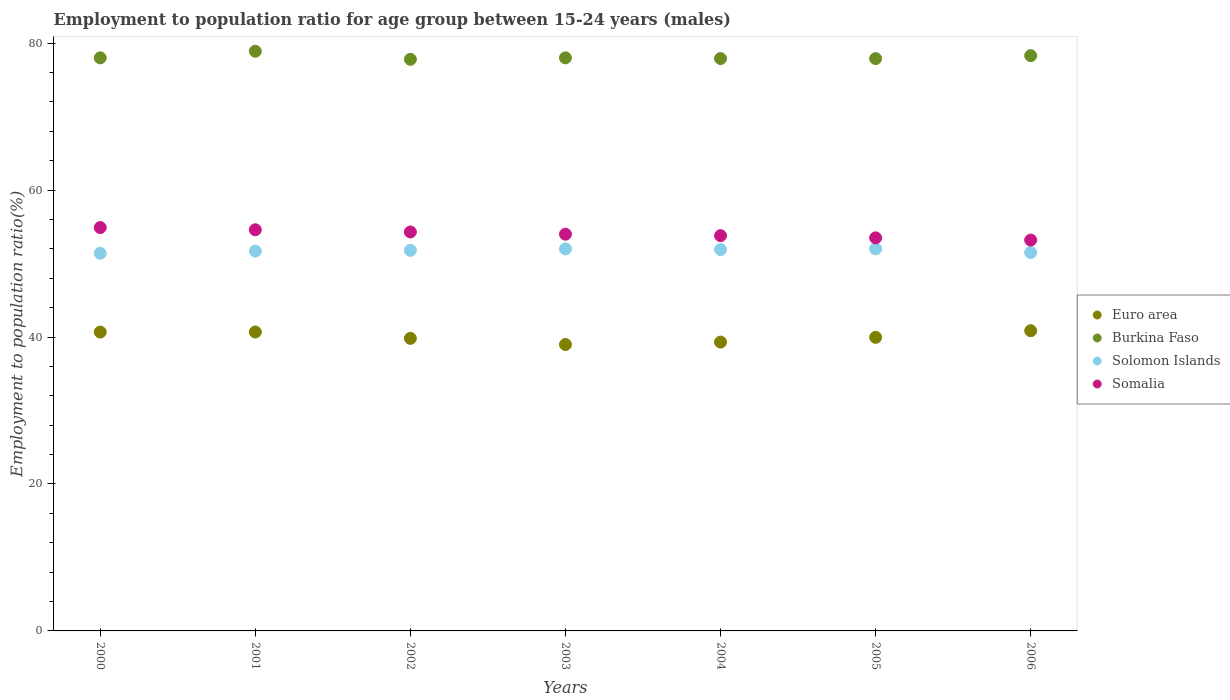How many different coloured dotlines are there?
Offer a terse response. 4. What is the employment to population ratio in Euro area in 2000?
Your answer should be very brief. 40.68. Across all years, what is the maximum employment to population ratio in Somalia?
Keep it short and to the point. 54.9. Across all years, what is the minimum employment to population ratio in Solomon Islands?
Your response must be concise. 51.4. In which year was the employment to population ratio in Solomon Islands minimum?
Your answer should be very brief. 2000. What is the total employment to population ratio in Solomon Islands in the graph?
Ensure brevity in your answer.  362.3. What is the difference between the employment to population ratio in Solomon Islands in 2003 and that in 2006?
Ensure brevity in your answer.  0.5. What is the difference between the employment to population ratio in Burkina Faso in 2004 and the employment to population ratio in Somalia in 2001?
Give a very brief answer. 23.3. What is the average employment to population ratio in Somalia per year?
Provide a succinct answer. 54.04. In the year 2001, what is the difference between the employment to population ratio in Solomon Islands and employment to population ratio in Euro area?
Offer a terse response. 11.02. In how many years, is the employment to population ratio in Solomon Islands greater than 48 %?
Your answer should be compact. 7. What is the ratio of the employment to population ratio in Somalia in 2001 to that in 2004?
Provide a short and direct response. 1.01. Is the employment to population ratio in Burkina Faso in 2000 less than that in 2001?
Provide a succinct answer. Yes. What is the difference between the highest and the second highest employment to population ratio in Somalia?
Keep it short and to the point. 0.3. What is the difference between the highest and the lowest employment to population ratio in Euro area?
Offer a very short reply. 1.88. Does the employment to population ratio in Euro area monotonically increase over the years?
Provide a succinct answer. No. What is the difference between two consecutive major ticks on the Y-axis?
Make the answer very short. 20. Does the graph contain any zero values?
Keep it short and to the point. No. How many legend labels are there?
Your answer should be compact. 4. What is the title of the graph?
Your answer should be compact. Employment to population ratio for age group between 15-24 years (males). What is the label or title of the Y-axis?
Your response must be concise. Employment to population ratio(%). What is the Employment to population ratio(%) of Euro area in 2000?
Make the answer very short. 40.68. What is the Employment to population ratio(%) of Solomon Islands in 2000?
Provide a succinct answer. 51.4. What is the Employment to population ratio(%) of Somalia in 2000?
Provide a succinct answer. 54.9. What is the Employment to population ratio(%) in Euro area in 2001?
Offer a very short reply. 40.68. What is the Employment to population ratio(%) in Burkina Faso in 2001?
Your response must be concise. 78.9. What is the Employment to population ratio(%) in Solomon Islands in 2001?
Keep it short and to the point. 51.7. What is the Employment to population ratio(%) of Somalia in 2001?
Offer a terse response. 54.6. What is the Employment to population ratio(%) in Euro area in 2002?
Keep it short and to the point. 39.82. What is the Employment to population ratio(%) in Burkina Faso in 2002?
Make the answer very short. 77.8. What is the Employment to population ratio(%) of Solomon Islands in 2002?
Ensure brevity in your answer.  51.8. What is the Employment to population ratio(%) of Somalia in 2002?
Your answer should be very brief. 54.3. What is the Employment to population ratio(%) of Euro area in 2003?
Provide a short and direct response. 38.98. What is the Employment to population ratio(%) of Burkina Faso in 2003?
Keep it short and to the point. 78. What is the Employment to population ratio(%) in Solomon Islands in 2003?
Your answer should be very brief. 52. What is the Employment to population ratio(%) in Somalia in 2003?
Your answer should be compact. 54. What is the Employment to population ratio(%) in Euro area in 2004?
Provide a succinct answer. 39.31. What is the Employment to population ratio(%) of Burkina Faso in 2004?
Your answer should be very brief. 77.9. What is the Employment to population ratio(%) of Solomon Islands in 2004?
Keep it short and to the point. 51.9. What is the Employment to population ratio(%) in Somalia in 2004?
Ensure brevity in your answer.  53.8. What is the Employment to population ratio(%) of Euro area in 2005?
Offer a very short reply. 39.96. What is the Employment to population ratio(%) of Burkina Faso in 2005?
Ensure brevity in your answer.  77.9. What is the Employment to population ratio(%) in Somalia in 2005?
Your response must be concise. 53.5. What is the Employment to population ratio(%) in Euro area in 2006?
Offer a very short reply. 40.86. What is the Employment to population ratio(%) in Burkina Faso in 2006?
Make the answer very short. 78.3. What is the Employment to population ratio(%) in Solomon Islands in 2006?
Ensure brevity in your answer.  51.5. What is the Employment to population ratio(%) of Somalia in 2006?
Give a very brief answer. 53.2. Across all years, what is the maximum Employment to population ratio(%) of Euro area?
Offer a very short reply. 40.86. Across all years, what is the maximum Employment to population ratio(%) of Burkina Faso?
Offer a terse response. 78.9. Across all years, what is the maximum Employment to population ratio(%) of Somalia?
Your response must be concise. 54.9. Across all years, what is the minimum Employment to population ratio(%) in Euro area?
Ensure brevity in your answer.  38.98. Across all years, what is the minimum Employment to population ratio(%) of Burkina Faso?
Your answer should be very brief. 77.8. Across all years, what is the minimum Employment to population ratio(%) in Solomon Islands?
Provide a succinct answer. 51.4. Across all years, what is the minimum Employment to population ratio(%) in Somalia?
Offer a very short reply. 53.2. What is the total Employment to population ratio(%) in Euro area in the graph?
Give a very brief answer. 280.3. What is the total Employment to population ratio(%) of Burkina Faso in the graph?
Keep it short and to the point. 546.8. What is the total Employment to population ratio(%) in Solomon Islands in the graph?
Provide a short and direct response. 362.3. What is the total Employment to population ratio(%) in Somalia in the graph?
Offer a terse response. 378.3. What is the difference between the Employment to population ratio(%) of Euro area in 2000 and that in 2001?
Provide a succinct answer. -0.01. What is the difference between the Employment to population ratio(%) of Solomon Islands in 2000 and that in 2001?
Offer a terse response. -0.3. What is the difference between the Employment to population ratio(%) in Euro area in 2000 and that in 2002?
Offer a terse response. 0.85. What is the difference between the Employment to population ratio(%) in Solomon Islands in 2000 and that in 2002?
Provide a succinct answer. -0.4. What is the difference between the Employment to population ratio(%) of Somalia in 2000 and that in 2002?
Keep it short and to the point. 0.6. What is the difference between the Employment to population ratio(%) of Euro area in 2000 and that in 2003?
Your answer should be very brief. 1.69. What is the difference between the Employment to population ratio(%) of Burkina Faso in 2000 and that in 2003?
Keep it short and to the point. 0. What is the difference between the Employment to population ratio(%) of Euro area in 2000 and that in 2004?
Keep it short and to the point. 1.36. What is the difference between the Employment to population ratio(%) in Burkina Faso in 2000 and that in 2004?
Provide a short and direct response. 0.1. What is the difference between the Employment to population ratio(%) of Solomon Islands in 2000 and that in 2004?
Your response must be concise. -0.5. What is the difference between the Employment to population ratio(%) in Euro area in 2000 and that in 2005?
Give a very brief answer. 0.72. What is the difference between the Employment to population ratio(%) in Solomon Islands in 2000 and that in 2005?
Offer a terse response. -0.6. What is the difference between the Employment to population ratio(%) in Somalia in 2000 and that in 2005?
Offer a terse response. 1.4. What is the difference between the Employment to population ratio(%) of Euro area in 2000 and that in 2006?
Keep it short and to the point. -0.19. What is the difference between the Employment to population ratio(%) in Somalia in 2000 and that in 2006?
Your response must be concise. 1.7. What is the difference between the Employment to population ratio(%) in Euro area in 2001 and that in 2002?
Give a very brief answer. 0.86. What is the difference between the Employment to population ratio(%) in Burkina Faso in 2001 and that in 2002?
Offer a very short reply. 1.1. What is the difference between the Employment to population ratio(%) in Somalia in 2001 and that in 2002?
Provide a succinct answer. 0.3. What is the difference between the Employment to population ratio(%) in Euro area in 2001 and that in 2003?
Your answer should be compact. 1.7. What is the difference between the Employment to population ratio(%) in Burkina Faso in 2001 and that in 2003?
Offer a terse response. 0.9. What is the difference between the Employment to population ratio(%) in Euro area in 2001 and that in 2004?
Provide a succinct answer. 1.37. What is the difference between the Employment to population ratio(%) of Burkina Faso in 2001 and that in 2004?
Your answer should be very brief. 1. What is the difference between the Employment to population ratio(%) in Euro area in 2001 and that in 2005?
Keep it short and to the point. 0.73. What is the difference between the Employment to population ratio(%) of Somalia in 2001 and that in 2005?
Ensure brevity in your answer.  1.1. What is the difference between the Employment to population ratio(%) of Euro area in 2001 and that in 2006?
Your answer should be very brief. -0.18. What is the difference between the Employment to population ratio(%) of Burkina Faso in 2001 and that in 2006?
Ensure brevity in your answer.  0.6. What is the difference between the Employment to population ratio(%) of Solomon Islands in 2001 and that in 2006?
Offer a very short reply. 0.2. What is the difference between the Employment to population ratio(%) in Euro area in 2002 and that in 2003?
Your answer should be compact. 0.84. What is the difference between the Employment to population ratio(%) of Burkina Faso in 2002 and that in 2003?
Make the answer very short. -0.2. What is the difference between the Employment to population ratio(%) of Euro area in 2002 and that in 2004?
Provide a succinct answer. 0.51. What is the difference between the Employment to population ratio(%) of Burkina Faso in 2002 and that in 2004?
Offer a very short reply. -0.1. What is the difference between the Employment to population ratio(%) of Solomon Islands in 2002 and that in 2004?
Provide a short and direct response. -0.1. What is the difference between the Employment to population ratio(%) in Somalia in 2002 and that in 2004?
Ensure brevity in your answer.  0.5. What is the difference between the Employment to population ratio(%) of Euro area in 2002 and that in 2005?
Your answer should be very brief. -0.14. What is the difference between the Employment to population ratio(%) in Solomon Islands in 2002 and that in 2005?
Offer a very short reply. -0.2. What is the difference between the Employment to population ratio(%) in Somalia in 2002 and that in 2005?
Ensure brevity in your answer.  0.8. What is the difference between the Employment to population ratio(%) of Euro area in 2002 and that in 2006?
Make the answer very short. -1.04. What is the difference between the Employment to population ratio(%) in Somalia in 2002 and that in 2006?
Provide a succinct answer. 1.1. What is the difference between the Employment to population ratio(%) in Euro area in 2003 and that in 2004?
Your answer should be very brief. -0.33. What is the difference between the Employment to population ratio(%) in Burkina Faso in 2003 and that in 2004?
Keep it short and to the point. 0.1. What is the difference between the Employment to population ratio(%) of Somalia in 2003 and that in 2004?
Give a very brief answer. 0.2. What is the difference between the Employment to population ratio(%) of Euro area in 2003 and that in 2005?
Provide a short and direct response. -0.97. What is the difference between the Employment to population ratio(%) of Somalia in 2003 and that in 2005?
Offer a terse response. 0.5. What is the difference between the Employment to population ratio(%) of Euro area in 2003 and that in 2006?
Provide a short and direct response. -1.88. What is the difference between the Employment to population ratio(%) in Somalia in 2003 and that in 2006?
Your answer should be very brief. 0.8. What is the difference between the Employment to population ratio(%) of Euro area in 2004 and that in 2005?
Provide a succinct answer. -0.64. What is the difference between the Employment to population ratio(%) of Somalia in 2004 and that in 2005?
Provide a succinct answer. 0.3. What is the difference between the Employment to population ratio(%) in Euro area in 2004 and that in 2006?
Provide a short and direct response. -1.55. What is the difference between the Employment to population ratio(%) of Burkina Faso in 2004 and that in 2006?
Provide a short and direct response. -0.4. What is the difference between the Employment to population ratio(%) in Euro area in 2005 and that in 2006?
Your answer should be very brief. -0.9. What is the difference between the Employment to population ratio(%) in Solomon Islands in 2005 and that in 2006?
Your answer should be very brief. 0.5. What is the difference between the Employment to population ratio(%) of Euro area in 2000 and the Employment to population ratio(%) of Burkina Faso in 2001?
Your response must be concise. -38.22. What is the difference between the Employment to population ratio(%) in Euro area in 2000 and the Employment to population ratio(%) in Solomon Islands in 2001?
Provide a short and direct response. -11.02. What is the difference between the Employment to population ratio(%) of Euro area in 2000 and the Employment to population ratio(%) of Somalia in 2001?
Give a very brief answer. -13.92. What is the difference between the Employment to population ratio(%) of Burkina Faso in 2000 and the Employment to population ratio(%) of Solomon Islands in 2001?
Give a very brief answer. 26.3. What is the difference between the Employment to population ratio(%) in Burkina Faso in 2000 and the Employment to population ratio(%) in Somalia in 2001?
Keep it short and to the point. 23.4. What is the difference between the Employment to population ratio(%) of Euro area in 2000 and the Employment to population ratio(%) of Burkina Faso in 2002?
Provide a short and direct response. -37.12. What is the difference between the Employment to population ratio(%) of Euro area in 2000 and the Employment to population ratio(%) of Solomon Islands in 2002?
Offer a terse response. -11.12. What is the difference between the Employment to population ratio(%) in Euro area in 2000 and the Employment to population ratio(%) in Somalia in 2002?
Keep it short and to the point. -13.62. What is the difference between the Employment to population ratio(%) in Burkina Faso in 2000 and the Employment to population ratio(%) in Solomon Islands in 2002?
Give a very brief answer. 26.2. What is the difference between the Employment to population ratio(%) in Burkina Faso in 2000 and the Employment to population ratio(%) in Somalia in 2002?
Make the answer very short. 23.7. What is the difference between the Employment to population ratio(%) in Solomon Islands in 2000 and the Employment to population ratio(%) in Somalia in 2002?
Keep it short and to the point. -2.9. What is the difference between the Employment to population ratio(%) in Euro area in 2000 and the Employment to population ratio(%) in Burkina Faso in 2003?
Your answer should be compact. -37.32. What is the difference between the Employment to population ratio(%) of Euro area in 2000 and the Employment to population ratio(%) of Solomon Islands in 2003?
Offer a very short reply. -11.32. What is the difference between the Employment to population ratio(%) in Euro area in 2000 and the Employment to population ratio(%) in Somalia in 2003?
Your response must be concise. -13.32. What is the difference between the Employment to population ratio(%) of Burkina Faso in 2000 and the Employment to population ratio(%) of Solomon Islands in 2003?
Ensure brevity in your answer.  26. What is the difference between the Employment to population ratio(%) in Solomon Islands in 2000 and the Employment to population ratio(%) in Somalia in 2003?
Make the answer very short. -2.6. What is the difference between the Employment to population ratio(%) in Euro area in 2000 and the Employment to population ratio(%) in Burkina Faso in 2004?
Your answer should be compact. -37.22. What is the difference between the Employment to population ratio(%) of Euro area in 2000 and the Employment to population ratio(%) of Solomon Islands in 2004?
Provide a short and direct response. -11.22. What is the difference between the Employment to population ratio(%) of Euro area in 2000 and the Employment to population ratio(%) of Somalia in 2004?
Your answer should be very brief. -13.12. What is the difference between the Employment to population ratio(%) in Burkina Faso in 2000 and the Employment to population ratio(%) in Solomon Islands in 2004?
Your response must be concise. 26.1. What is the difference between the Employment to population ratio(%) of Burkina Faso in 2000 and the Employment to population ratio(%) of Somalia in 2004?
Make the answer very short. 24.2. What is the difference between the Employment to population ratio(%) of Euro area in 2000 and the Employment to population ratio(%) of Burkina Faso in 2005?
Offer a terse response. -37.22. What is the difference between the Employment to population ratio(%) in Euro area in 2000 and the Employment to population ratio(%) in Solomon Islands in 2005?
Offer a very short reply. -11.32. What is the difference between the Employment to population ratio(%) of Euro area in 2000 and the Employment to population ratio(%) of Somalia in 2005?
Provide a short and direct response. -12.82. What is the difference between the Employment to population ratio(%) in Burkina Faso in 2000 and the Employment to population ratio(%) in Solomon Islands in 2005?
Your answer should be compact. 26. What is the difference between the Employment to population ratio(%) in Euro area in 2000 and the Employment to population ratio(%) in Burkina Faso in 2006?
Offer a very short reply. -37.62. What is the difference between the Employment to population ratio(%) of Euro area in 2000 and the Employment to population ratio(%) of Solomon Islands in 2006?
Provide a succinct answer. -10.82. What is the difference between the Employment to population ratio(%) in Euro area in 2000 and the Employment to population ratio(%) in Somalia in 2006?
Ensure brevity in your answer.  -12.52. What is the difference between the Employment to population ratio(%) in Burkina Faso in 2000 and the Employment to population ratio(%) in Somalia in 2006?
Keep it short and to the point. 24.8. What is the difference between the Employment to population ratio(%) of Solomon Islands in 2000 and the Employment to population ratio(%) of Somalia in 2006?
Keep it short and to the point. -1.8. What is the difference between the Employment to population ratio(%) of Euro area in 2001 and the Employment to population ratio(%) of Burkina Faso in 2002?
Keep it short and to the point. -37.12. What is the difference between the Employment to population ratio(%) of Euro area in 2001 and the Employment to population ratio(%) of Solomon Islands in 2002?
Offer a terse response. -11.12. What is the difference between the Employment to population ratio(%) of Euro area in 2001 and the Employment to population ratio(%) of Somalia in 2002?
Provide a succinct answer. -13.62. What is the difference between the Employment to population ratio(%) of Burkina Faso in 2001 and the Employment to population ratio(%) of Solomon Islands in 2002?
Your response must be concise. 27.1. What is the difference between the Employment to population ratio(%) in Burkina Faso in 2001 and the Employment to population ratio(%) in Somalia in 2002?
Your response must be concise. 24.6. What is the difference between the Employment to population ratio(%) in Solomon Islands in 2001 and the Employment to population ratio(%) in Somalia in 2002?
Offer a very short reply. -2.6. What is the difference between the Employment to population ratio(%) in Euro area in 2001 and the Employment to population ratio(%) in Burkina Faso in 2003?
Offer a very short reply. -37.32. What is the difference between the Employment to population ratio(%) of Euro area in 2001 and the Employment to population ratio(%) of Solomon Islands in 2003?
Provide a short and direct response. -11.32. What is the difference between the Employment to population ratio(%) of Euro area in 2001 and the Employment to population ratio(%) of Somalia in 2003?
Ensure brevity in your answer.  -13.32. What is the difference between the Employment to population ratio(%) of Burkina Faso in 2001 and the Employment to population ratio(%) of Solomon Islands in 2003?
Offer a terse response. 26.9. What is the difference between the Employment to population ratio(%) of Burkina Faso in 2001 and the Employment to population ratio(%) of Somalia in 2003?
Keep it short and to the point. 24.9. What is the difference between the Employment to population ratio(%) in Solomon Islands in 2001 and the Employment to population ratio(%) in Somalia in 2003?
Keep it short and to the point. -2.3. What is the difference between the Employment to population ratio(%) of Euro area in 2001 and the Employment to population ratio(%) of Burkina Faso in 2004?
Ensure brevity in your answer.  -37.22. What is the difference between the Employment to population ratio(%) in Euro area in 2001 and the Employment to population ratio(%) in Solomon Islands in 2004?
Ensure brevity in your answer.  -11.22. What is the difference between the Employment to population ratio(%) in Euro area in 2001 and the Employment to population ratio(%) in Somalia in 2004?
Offer a very short reply. -13.12. What is the difference between the Employment to population ratio(%) of Burkina Faso in 2001 and the Employment to population ratio(%) of Solomon Islands in 2004?
Ensure brevity in your answer.  27. What is the difference between the Employment to population ratio(%) of Burkina Faso in 2001 and the Employment to population ratio(%) of Somalia in 2004?
Your answer should be compact. 25.1. What is the difference between the Employment to population ratio(%) of Euro area in 2001 and the Employment to population ratio(%) of Burkina Faso in 2005?
Your response must be concise. -37.22. What is the difference between the Employment to population ratio(%) of Euro area in 2001 and the Employment to population ratio(%) of Solomon Islands in 2005?
Your answer should be very brief. -11.32. What is the difference between the Employment to population ratio(%) of Euro area in 2001 and the Employment to population ratio(%) of Somalia in 2005?
Ensure brevity in your answer.  -12.82. What is the difference between the Employment to population ratio(%) of Burkina Faso in 2001 and the Employment to population ratio(%) of Solomon Islands in 2005?
Your answer should be very brief. 26.9. What is the difference between the Employment to population ratio(%) of Burkina Faso in 2001 and the Employment to population ratio(%) of Somalia in 2005?
Your answer should be very brief. 25.4. What is the difference between the Employment to population ratio(%) in Euro area in 2001 and the Employment to population ratio(%) in Burkina Faso in 2006?
Provide a succinct answer. -37.62. What is the difference between the Employment to population ratio(%) of Euro area in 2001 and the Employment to population ratio(%) of Solomon Islands in 2006?
Keep it short and to the point. -10.82. What is the difference between the Employment to population ratio(%) in Euro area in 2001 and the Employment to population ratio(%) in Somalia in 2006?
Make the answer very short. -12.52. What is the difference between the Employment to population ratio(%) of Burkina Faso in 2001 and the Employment to population ratio(%) of Solomon Islands in 2006?
Make the answer very short. 27.4. What is the difference between the Employment to population ratio(%) of Burkina Faso in 2001 and the Employment to population ratio(%) of Somalia in 2006?
Ensure brevity in your answer.  25.7. What is the difference between the Employment to population ratio(%) of Euro area in 2002 and the Employment to population ratio(%) of Burkina Faso in 2003?
Offer a terse response. -38.18. What is the difference between the Employment to population ratio(%) of Euro area in 2002 and the Employment to population ratio(%) of Solomon Islands in 2003?
Your answer should be very brief. -12.18. What is the difference between the Employment to population ratio(%) of Euro area in 2002 and the Employment to population ratio(%) of Somalia in 2003?
Your response must be concise. -14.18. What is the difference between the Employment to population ratio(%) of Burkina Faso in 2002 and the Employment to population ratio(%) of Solomon Islands in 2003?
Give a very brief answer. 25.8. What is the difference between the Employment to population ratio(%) in Burkina Faso in 2002 and the Employment to population ratio(%) in Somalia in 2003?
Give a very brief answer. 23.8. What is the difference between the Employment to population ratio(%) of Solomon Islands in 2002 and the Employment to population ratio(%) of Somalia in 2003?
Provide a short and direct response. -2.2. What is the difference between the Employment to population ratio(%) of Euro area in 2002 and the Employment to population ratio(%) of Burkina Faso in 2004?
Offer a terse response. -38.08. What is the difference between the Employment to population ratio(%) of Euro area in 2002 and the Employment to population ratio(%) of Solomon Islands in 2004?
Your answer should be compact. -12.08. What is the difference between the Employment to population ratio(%) of Euro area in 2002 and the Employment to population ratio(%) of Somalia in 2004?
Your answer should be compact. -13.98. What is the difference between the Employment to population ratio(%) of Burkina Faso in 2002 and the Employment to population ratio(%) of Solomon Islands in 2004?
Offer a terse response. 25.9. What is the difference between the Employment to population ratio(%) in Burkina Faso in 2002 and the Employment to population ratio(%) in Somalia in 2004?
Your response must be concise. 24. What is the difference between the Employment to population ratio(%) in Solomon Islands in 2002 and the Employment to population ratio(%) in Somalia in 2004?
Ensure brevity in your answer.  -2. What is the difference between the Employment to population ratio(%) of Euro area in 2002 and the Employment to population ratio(%) of Burkina Faso in 2005?
Give a very brief answer. -38.08. What is the difference between the Employment to population ratio(%) of Euro area in 2002 and the Employment to population ratio(%) of Solomon Islands in 2005?
Give a very brief answer. -12.18. What is the difference between the Employment to population ratio(%) of Euro area in 2002 and the Employment to population ratio(%) of Somalia in 2005?
Make the answer very short. -13.68. What is the difference between the Employment to population ratio(%) of Burkina Faso in 2002 and the Employment to population ratio(%) of Solomon Islands in 2005?
Your answer should be compact. 25.8. What is the difference between the Employment to population ratio(%) of Burkina Faso in 2002 and the Employment to population ratio(%) of Somalia in 2005?
Give a very brief answer. 24.3. What is the difference between the Employment to population ratio(%) in Solomon Islands in 2002 and the Employment to population ratio(%) in Somalia in 2005?
Ensure brevity in your answer.  -1.7. What is the difference between the Employment to population ratio(%) in Euro area in 2002 and the Employment to population ratio(%) in Burkina Faso in 2006?
Keep it short and to the point. -38.48. What is the difference between the Employment to population ratio(%) in Euro area in 2002 and the Employment to population ratio(%) in Solomon Islands in 2006?
Offer a very short reply. -11.68. What is the difference between the Employment to population ratio(%) in Euro area in 2002 and the Employment to population ratio(%) in Somalia in 2006?
Provide a short and direct response. -13.38. What is the difference between the Employment to population ratio(%) of Burkina Faso in 2002 and the Employment to population ratio(%) of Solomon Islands in 2006?
Make the answer very short. 26.3. What is the difference between the Employment to population ratio(%) of Burkina Faso in 2002 and the Employment to population ratio(%) of Somalia in 2006?
Give a very brief answer. 24.6. What is the difference between the Employment to population ratio(%) in Euro area in 2003 and the Employment to population ratio(%) in Burkina Faso in 2004?
Provide a succinct answer. -38.92. What is the difference between the Employment to population ratio(%) of Euro area in 2003 and the Employment to population ratio(%) of Solomon Islands in 2004?
Offer a very short reply. -12.92. What is the difference between the Employment to population ratio(%) of Euro area in 2003 and the Employment to population ratio(%) of Somalia in 2004?
Provide a succinct answer. -14.82. What is the difference between the Employment to population ratio(%) of Burkina Faso in 2003 and the Employment to population ratio(%) of Solomon Islands in 2004?
Your response must be concise. 26.1. What is the difference between the Employment to population ratio(%) in Burkina Faso in 2003 and the Employment to population ratio(%) in Somalia in 2004?
Your answer should be very brief. 24.2. What is the difference between the Employment to population ratio(%) of Solomon Islands in 2003 and the Employment to population ratio(%) of Somalia in 2004?
Offer a terse response. -1.8. What is the difference between the Employment to population ratio(%) in Euro area in 2003 and the Employment to population ratio(%) in Burkina Faso in 2005?
Ensure brevity in your answer.  -38.92. What is the difference between the Employment to population ratio(%) of Euro area in 2003 and the Employment to population ratio(%) of Solomon Islands in 2005?
Your answer should be very brief. -13.02. What is the difference between the Employment to population ratio(%) of Euro area in 2003 and the Employment to population ratio(%) of Somalia in 2005?
Your answer should be compact. -14.52. What is the difference between the Employment to population ratio(%) in Solomon Islands in 2003 and the Employment to population ratio(%) in Somalia in 2005?
Provide a short and direct response. -1.5. What is the difference between the Employment to population ratio(%) in Euro area in 2003 and the Employment to population ratio(%) in Burkina Faso in 2006?
Keep it short and to the point. -39.32. What is the difference between the Employment to population ratio(%) of Euro area in 2003 and the Employment to population ratio(%) of Solomon Islands in 2006?
Your response must be concise. -12.52. What is the difference between the Employment to population ratio(%) in Euro area in 2003 and the Employment to population ratio(%) in Somalia in 2006?
Your answer should be compact. -14.22. What is the difference between the Employment to population ratio(%) of Burkina Faso in 2003 and the Employment to population ratio(%) of Somalia in 2006?
Make the answer very short. 24.8. What is the difference between the Employment to population ratio(%) in Solomon Islands in 2003 and the Employment to population ratio(%) in Somalia in 2006?
Ensure brevity in your answer.  -1.2. What is the difference between the Employment to population ratio(%) in Euro area in 2004 and the Employment to population ratio(%) in Burkina Faso in 2005?
Ensure brevity in your answer.  -38.59. What is the difference between the Employment to population ratio(%) of Euro area in 2004 and the Employment to population ratio(%) of Solomon Islands in 2005?
Provide a short and direct response. -12.69. What is the difference between the Employment to population ratio(%) of Euro area in 2004 and the Employment to population ratio(%) of Somalia in 2005?
Keep it short and to the point. -14.19. What is the difference between the Employment to population ratio(%) of Burkina Faso in 2004 and the Employment to population ratio(%) of Solomon Islands in 2005?
Your answer should be very brief. 25.9. What is the difference between the Employment to population ratio(%) of Burkina Faso in 2004 and the Employment to population ratio(%) of Somalia in 2005?
Offer a very short reply. 24.4. What is the difference between the Employment to population ratio(%) of Solomon Islands in 2004 and the Employment to population ratio(%) of Somalia in 2005?
Offer a very short reply. -1.6. What is the difference between the Employment to population ratio(%) of Euro area in 2004 and the Employment to population ratio(%) of Burkina Faso in 2006?
Offer a very short reply. -38.98. What is the difference between the Employment to population ratio(%) of Euro area in 2004 and the Employment to population ratio(%) of Solomon Islands in 2006?
Your answer should be very brief. -12.19. What is the difference between the Employment to population ratio(%) in Euro area in 2004 and the Employment to population ratio(%) in Somalia in 2006?
Make the answer very short. -13.88. What is the difference between the Employment to population ratio(%) in Burkina Faso in 2004 and the Employment to population ratio(%) in Solomon Islands in 2006?
Ensure brevity in your answer.  26.4. What is the difference between the Employment to population ratio(%) in Burkina Faso in 2004 and the Employment to population ratio(%) in Somalia in 2006?
Your answer should be compact. 24.7. What is the difference between the Employment to population ratio(%) in Solomon Islands in 2004 and the Employment to population ratio(%) in Somalia in 2006?
Your answer should be compact. -1.3. What is the difference between the Employment to population ratio(%) in Euro area in 2005 and the Employment to population ratio(%) in Burkina Faso in 2006?
Make the answer very short. -38.34. What is the difference between the Employment to population ratio(%) of Euro area in 2005 and the Employment to population ratio(%) of Solomon Islands in 2006?
Offer a terse response. -11.54. What is the difference between the Employment to population ratio(%) of Euro area in 2005 and the Employment to population ratio(%) of Somalia in 2006?
Your answer should be compact. -13.24. What is the difference between the Employment to population ratio(%) in Burkina Faso in 2005 and the Employment to population ratio(%) in Solomon Islands in 2006?
Provide a succinct answer. 26.4. What is the difference between the Employment to population ratio(%) of Burkina Faso in 2005 and the Employment to population ratio(%) of Somalia in 2006?
Ensure brevity in your answer.  24.7. What is the average Employment to population ratio(%) in Euro area per year?
Make the answer very short. 40.04. What is the average Employment to population ratio(%) in Burkina Faso per year?
Offer a very short reply. 78.11. What is the average Employment to population ratio(%) of Solomon Islands per year?
Keep it short and to the point. 51.76. What is the average Employment to population ratio(%) in Somalia per year?
Offer a terse response. 54.04. In the year 2000, what is the difference between the Employment to population ratio(%) in Euro area and Employment to population ratio(%) in Burkina Faso?
Your response must be concise. -37.32. In the year 2000, what is the difference between the Employment to population ratio(%) in Euro area and Employment to population ratio(%) in Solomon Islands?
Offer a terse response. -10.72. In the year 2000, what is the difference between the Employment to population ratio(%) in Euro area and Employment to population ratio(%) in Somalia?
Your answer should be compact. -14.22. In the year 2000, what is the difference between the Employment to population ratio(%) in Burkina Faso and Employment to population ratio(%) in Solomon Islands?
Your answer should be very brief. 26.6. In the year 2000, what is the difference between the Employment to population ratio(%) in Burkina Faso and Employment to population ratio(%) in Somalia?
Provide a succinct answer. 23.1. In the year 2001, what is the difference between the Employment to population ratio(%) in Euro area and Employment to population ratio(%) in Burkina Faso?
Your answer should be very brief. -38.22. In the year 2001, what is the difference between the Employment to population ratio(%) of Euro area and Employment to population ratio(%) of Solomon Islands?
Make the answer very short. -11.02. In the year 2001, what is the difference between the Employment to population ratio(%) of Euro area and Employment to population ratio(%) of Somalia?
Give a very brief answer. -13.92. In the year 2001, what is the difference between the Employment to population ratio(%) of Burkina Faso and Employment to population ratio(%) of Solomon Islands?
Ensure brevity in your answer.  27.2. In the year 2001, what is the difference between the Employment to population ratio(%) in Burkina Faso and Employment to population ratio(%) in Somalia?
Provide a short and direct response. 24.3. In the year 2001, what is the difference between the Employment to population ratio(%) of Solomon Islands and Employment to population ratio(%) of Somalia?
Provide a succinct answer. -2.9. In the year 2002, what is the difference between the Employment to population ratio(%) of Euro area and Employment to population ratio(%) of Burkina Faso?
Make the answer very short. -37.98. In the year 2002, what is the difference between the Employment to population ratio(%) of Euro area and Employment to population ratio(%) of Solomon Islands?
Your response must be concise. -11.98. In the year 2002, what is the difference between the Employment to population ratio(%) in Euro area and Employment to population ratio(%) in Somalia?
Offer a very short reply. -14.48. In the year 2002, what is the difference between the Employment to population ratio(%) of Burkina Faso and Employment to population ratio(%) of Somalia?
Provide a short and direct response. 23.5. In the year 2003, what is the difference between the Employment to population ratio(%) in Euro area and Employment to population ratio(%) in Burkina Faso?
Your answer should be very brief. -39.02. In the year 2003, what is the difference between the Employment to population ratio(%) in Euro area and Employment to population ratio(%) in Solomon Islands?
Give a very brief answer. -13.02. In the year 2003, what is the difference between the Employment to population ratio(%) of Euro area and Employment to population ratio(%) of Somalia?
Make the answer very short. -15.02. In the year 2004, what is the difference between the Employment to population ratio(%) of Euro area and Employment to population ratio(%) of Burkina Faso?
Make the answer very short. -38.59. In the year 2004, what is the difference between the Employment to population ratio(%) of Euro area and Employment to population ratio(%) of Solomon Islands?
Your answer should be very brief. -12.59. In the year 2004, what is the difference between the Employment to population ratio(%) of Euro area and Employment to population ratio(%) of Somalia?
Ensure brevity in your answer.  -14.48. In the year 2004, what is the difference between the Employment to population ratio(%) of Burkina Faso and Employment to population ratio(%) of Solomon Islands?
Your answer should be very brief. 26. In the year 2004, what is the difference between the Employment to population ratio(%) of Burkina Faso and Employment to population ratio(%) of Somalia?
Ensure brevity in your answer.  24.1. In the year 2005, what is the difference between the Employment to population ratio(%) of Euro area and Employment to population ratio(%) of Burkina Faso?
Make the answer very short. -37.94. In the year 2005, what is the difference between the Employment to population ratio(%) of Euro area and Employment to population ratio(%) of Solomon Islands?
Offer a very short reply. -12.04. In the year 2005, what is the difference between the Employment to population ratio(%) of Euro area and Employment to population ratio(%) of Somalia?
Keep it short and to the point. -13.54. In the year 2005, what is the difference between the Employment to population ratio(%) of Burkina Faso and Employment to population ratio(%) of Solomon Islands?
Provide a short and direct response. 25.9. In the year 2005, what is the difference between the Employment to population ratio(%) of Burkina Faso and Employment to population ratio(%) of Somalia?
Offer a terse response. 24.4. In the year 2006, what is the difference between the Employment to population ratio(%) of Euro area and Employment to population ratio(%) of Burkina Faso?
Offer a very short reply. -37.44. In the year 2006, what is the difference between the Employment to population ratio(%) of Euro area and Employment to population ratio(%) of Solomon Islands?
Your response must be concise. -10.64. In the year 2006, what is the difference between the Employment to population ratio(%) of Euro area and Employment to population ratio(%) of Somalia?
Provide a short and direct response. -12.34. In the year 2006, what is the difference between the Employment to population ratio(%) of Burkina Faso and Employment to population ratio(%) of Solomon Islands?
Your answer should be compact. 26.8. In the year 2006, what is the difference between the Employment to population ratio(%) of Burkina Faso and Employment to population ratio(%) of Somalia?
Keep it short and to the point. 25.1. What is the ratio of the Employment to population ratio(%) of Euro area in 2000 to that in 2001?
Your answer should be compact. 1. What is the ratio of the Employment to population ratio(%) of Euro area in 2000 to that in 2002?
Make the answer very short. 1.02. What is the ratio of the Employment to population ratio(%) of Burkina Faso in 2000 to that in 2002?
Offer a very short reply. 1. What is the ratio of the Employment to population ratio(%) in Somalia in 2000 to that in 2002?
Offer a very short reply. 1.01. What is the ratio of the Employment to population ratio(%) in Euro area in 2000 to that in 2003?
Offer a very short reply. 1.04. What is the ratio of the Employment to population ratio(%) in Burkina Faso in 2000 to that in 2003?
Your answer should be compact. 1. What is the ratio of the Employment to population ratio(%) in Somalia in 2000 to that in 2003?
Offer a very short reply. 1.02. What is the ratio of the Employment to population ratio(%) of Euro area in 2000 to that in 2004?
Provide a succinct answer. 1.03. What is the ratio of the Employment to population ratio(%) of Solomon Islands in 2000 to that in 2004?
Make the answer very short. 0.99. What is the ratio of the Employment to population ratio(%) in Somalia in 2000 to that in 2004?
Your response must be concise. 1.02. What is the ratio of the Employment to population ratio(%) of Euro area in 2000 to that in 2005?
Keep it short and to the point. 1.02. What is the ratio of the Employment to population ratio(%) of Solomon Islands in 2000 to that in 2005?
Your answer should be compact. 0.99. What is the ratio of the Employment to population ratio(%) in Somalia in 2000 to that in 2005?
Your answer should be very brief. 1.03. What is the ratio of the Employment to population ratio(%) of Solomon Islands in 2000 to that in 2006?
Give a very brief answer. 1. What is the ratio of the Employment to population ratio(%) of Somalia in 2000 to that in 2006?
Your answer should be very brief. 1.03. What is the ratio of the Employment to population ratio(%) of Euro area in 2001 to that in 2002?
Give a very brief answer. 1.02. What is the ratio of the Employment to population ratio(%) in Burkina Faso in 2001 to that in 2002?
Offer a very short reply. 1.01. What is the ratio of the Employment to population ratio(%) in Solomon Islands in 2001 to that in 2002?
Make the answer very short. 1. What is the ratio of the Employment to population ratio(%) in Somalia in 2001 to that in 2002?
Provide a short and direct response. 1.01. What is the ratio of the Employment to population ratio(%) in Euro area in 2001 to that in 2003?
Ensure brevity in your answer.  1.04. What is the ratio of the Employment to population ratio(%) of Burkina Faso in 2001 to that in 2003?
Keep it short and to the point. 1.01. What is the ratio of the Employment to population ratio(%) in Solomon Islands in 2001 to that in 2003?
Offer a very short reply. 0.99. What is the ratio of the Employment to population ratio(%) in Somalia in 2001 to that in 2003?
Make the answer very short. 1.01. What is the ratio of the Employment to population ratio(%) of Euro area in 2001 to that in 2004?
Provide a succinct answer. 1.03. What is the ratio of the Employment to population ratio(%) of Burkina Faso in 2001 to that in 2004?
Your answer should be compact. 1.01. What is the ratio of the Employment to population ratio(%) of Solomon Islands in 2001 to that in 2004?
Offer a terse response. 1. What is the ratio of the Employment to population ratio(%) of Somalia in 2001 to that in 2004?
Ensure brevity in your answer.  1.01. What is the ratio of the Employment to population ratio(%) of Euro area in 2001 to that in 2005?
Ensure brevity in your answer.  1.02. What is the ratio of the Employment to population ratio(%) in Burkina Faso in 2001 to that in 2005?
Offer a very short reply. 1.01. What is the ratio of the Employment to population ratio(%) in Solomon Islands in 2001 to that in 2005?
Provide a short and direct response. 0.99. What is the ratio of the Employment to population ratio(%) in Somalia in 2001 to that in 2005?
Keep it short and to the point. 1.02. What is the ratio of the Employment to population ratio(%) in Euro area in 2001 to that in 2006?
Make the answer very short. 1. What is the ratio of the Employment to population ratio(%) in Burkina Faso in 2001 to that in 2006?
Offer a terse response. 1.01. What is the ratio of the Employment to population ratio(%) in Somalia in 2001 to that in 2006?
Make the answer very short. 1.03. What is the ratio of the Employment to population ratio(%) of Euro area in 2002 to that in 2003?
Your answer should be compact. 1.02. What is the ratio of the Employment to population ratio(%) in Solomon Islands in 2002 to that in 2003?
Provide a succinct answer. 1. What is the ratio of the Employment to population ratio(%) in Somalia in 2002 to that in 2003?
Ensure brevity in your answer.  1.01. What is the ratio of the Employment to population ratio(%) of Euro area in 2002 to that in 2004?
Ensure brevity in your answer.  1.01. What is the ratio of the Employment to population ratio(%) of Solomon Islands in 2002 to that in 2004?
Give a very brief answer. 1. What is the ratio of the Employment to population ratio(%) of Somalia in 2002 to that in 2004?
Give a very brief answer. 1.01. What is the ratio of the Employment to population ratio(%) in Burkina Faso in 2002 to that in 2005?
Provide a succinct answer. 1. What is the ratio of the Employment to population ratio(%) in Somalia in 2002 to that in 2005?
Your answer should be compact. 1.01. What is the ratio of the Employment to population ratio(%) of Euro area in 2002 to that in 2006?
Your answer should be compact. 0.97. What is the ratio of the Employment to population ratio(%) in Burkina Faso in 2002 to that in 2006?
Offer a terse response. 0.99. What is the ratio of the Employment to population ratio(%) in Somalia in 2002 to that in 2006?
Your answer should be compact. 1.02. What is the ratio of the Employment to population ratio(%) of Euro area in 2003 to that in 2004?
Provide a short and direct response. 0.99. What is the ratio of the Employment to population ratio(%) in Burkina Faso in 2003 to that in 2004?
Ensure brevity in your answer.  1. What is the ratio of the Employment to population ratio(%) in Euro area in 2003 to that in 2005?
Offer a very short reply. 0.98. What is the ratio of the Employment to population ratio(%) in Burkina Faso in 2003 to that in 2005?
Offer a very short reply. 1. What is the ratio of the Employment to population ratio(%) in Somalia in 2003 to that in 2005?
Give a very brief answer. 1.01. What is the ratio of the Employment to population ratio(%) in Euro area in 2003 to that in 2006?
Your answer should be compact. 0.95. What is the ratio of the Employment to population ratio(%) of Burkina Faso in 2003 to that in 2006?
Ensure brevity in your answer.  1. What is the ratio of the Employment to population ratio(%) in Solomon Islands in 2003 to that in 2006?
Keep it short and to the point. 1.01. What is the ratio of the Employment to population ratio(%) of Somalia in 2003 to that in 2006?
Keep it short and to the point. 1.01. What is the ratio of the Employment to population ratio(%) in Euro area in 2004 to that in 2005?
Your response must be concise. 0.98. What is the ratio of the Employment to population ratio(%) of Burkina Faso in 2004 to that in 2005?
Offer a very short reply. 1. What is the ratio of the Employment to population ratio(%) of Somalia in 2004 to that in 2005?
Make the answer very short. 1.01. What is the ratio of the Employment to population ratio(%) in Euro area in 2004 to that in 2006?
Your response must be concise. 0.96. What is the ratio of the Employment to population ratio(%) in Somalia in 2004 to that in 2006?
Keep it short and to the point. 1.01. What is the ratio of the Employment to population ratio(%) in Euro area in 2005 to that in 2006?
Give a very brief answer. 0.98. What is the ratio of the Employment to population ratio(%) of Solomon Islands in 2005 to that in 2006?
Keep it short and to the point. 1.01. What is the ratio of the Employment to population ratio(%) in Somalia in 2005 to that in 2006?
Make the answer very short. 1.01. What is the difference between the highest and the second highest Employment to population ratio(%) of Euro area?
Your response must be concise. 0.18. What is the difference between the highest and the second highest Employment to population ratio(%) in Burkina Faso?
Keep it short and to the point. 0.6. What is the difference between the highest and the lowest Employment to population ratio(%) of Euro area?
Your answer should be compact. 1.88. What is the difference between the highest and the lowest Employment to population ratio(%) in Burkina Faso?
Make the answer very short. 1.1. What is the difference between the highest and the lowest Employment to population ratio(%) of Solomon Islands?
Provide a short and direct response. 0.6. 